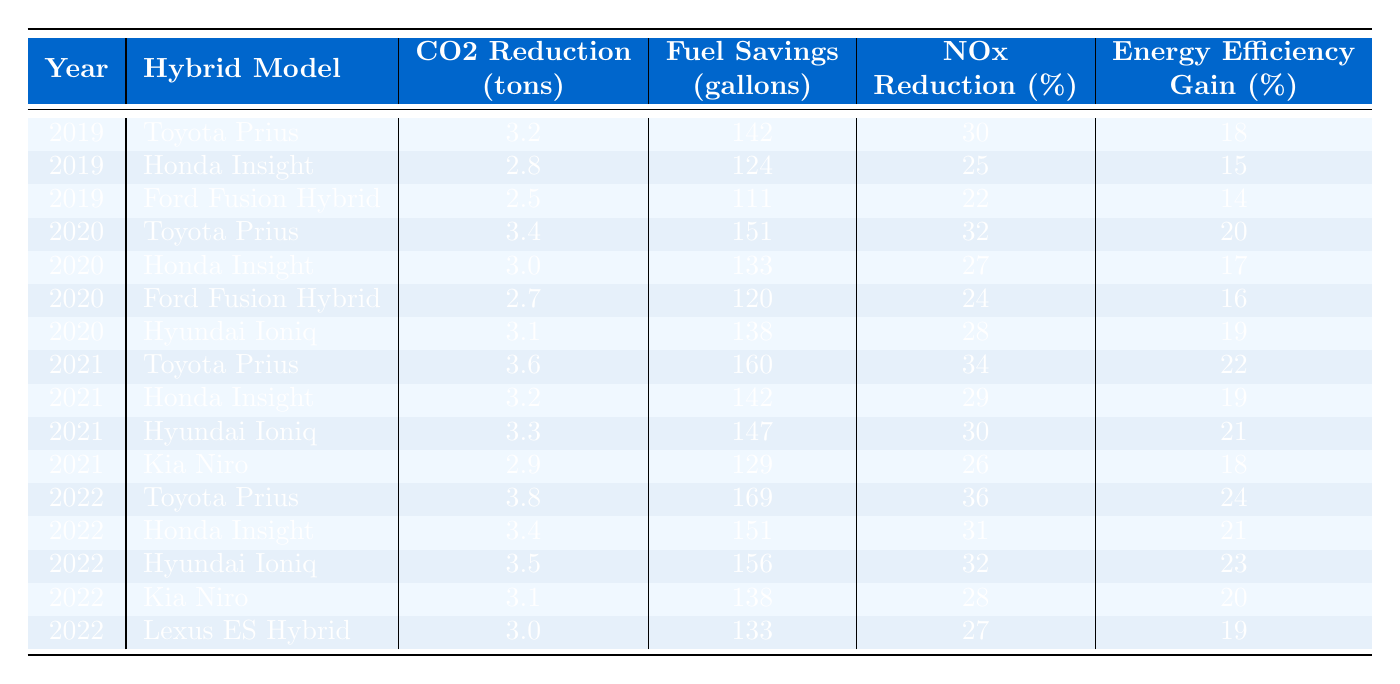What is the CO2 reduction from the Toyota Prius in 2021? In the table, we find the row for the Toyota Prius in 2021, which shows a CO2 reduction of 3.6 tons.
Answer: 3.6 tons Which hybrid model had the highest fuel savings in 2022? Looking at the 2022 data, the Toyota Prius has the highest fuel savings at 169 gallons.
Answer: Toyota Prius How many tons of CO2 was reduced by the Honda Insight in 2020? By checking the row for the Honda Insight in 2020, we see it shows a CO2 reduction of 3.0 tons.
Answer: 3.0 tons What is the total NOx reduction for all models in 2021? We take the NOx reduction percentages from all models in 2021: 34 + 29 + 30 + 26 = 119%.
Answer: 119% Was there an increase in the CO2 reduction for the Ford Fusion Hybrid from 2019 to 2020? The table shows that the Ford Fusion Hybrid reduced CO2 by 2.5 tons in 2019 and 2.7 tons in 2020, indicating an increase of 0.2 tons.
Answer: Yes Which hybrid model shows the largest increase in energy efficiency gain from 2020 to 2021? The energy efficiency gains for each model from 2020 to 2021 are analyzed: Toyota Prius increases by 2%, Honda Insight by 2%, Hyundai Ioniq by 3%, and Kia Niro by 2%. The largest increase is from the Hyundai Ioniq.
Answer: Hyundai Ioniq What is the average fuel savings across all models in 2022? We sum the fuel savings for all models in 2022: 169 + 151 + 156 + 138 + 133 = 747 gallons. There are 5 models, so the average is 747 / 5 = 149.4 gallons.
Answer: 149.4 gallons Does the Lexus ES Hybrid have the lowest NOx reduction percentage in 2022? Checking the 2022 NOx reduction percentages, we find it has 27%, which is less than all the other models (36%, 31%, 32%, 28%).
Answer: Yes Which model had the highest CO2 reduction over the four years displayed? We compare the CO2 reductions for each model across the years, with the Toyota Prius consistently showing the highest reduction of 3.8 tons in 2022, leading to a total of 14.4 tons across four years.
Answer: Toyota Prius How much CO2 was reduced by the Kia Niro in total over the four years? The Kia Niro's CO2 reductions are 2.9 tons (2021), 3.1 tons (2022), and it has no data for earlier years. Therefore, we only sum these for 2021 and 2022, which totals 6.0 tons.
Answer: 6.0 tons 